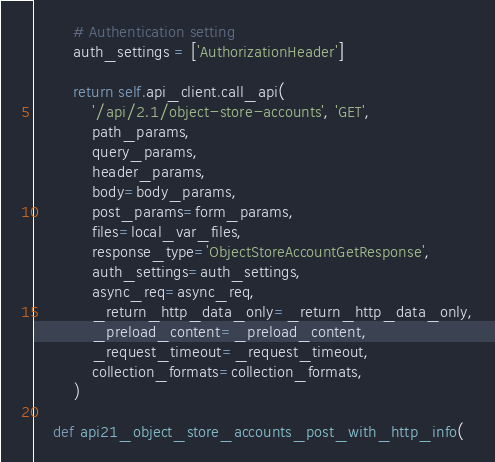Convert code to text. <code><loc_0><loc_0><loc_500><loc_500><_Python_>        # Authentication setting
        auth_settings = ['AuthorizationHeader']

        return self.api_client.call_api(
            '/api/2.1/object-store-accounts', 'GET',
            path_params,
            query_params,
            header_params,
            body=body_params,
            post_params=form_params,
            files=local_var_files,
            response_type='ObjectStoreAccountGetResponse',
            auth_settings=auth_settings,
            async_req=async_req,
            _return_http_data_only=_return_http_data_only,
            _preload_content=_preload_content,
            _request_timeout=_request_timeout,
            collection_formats=collection_formats,
        )

    def api21_object_store_accounts_post_with_http_info(</code> 